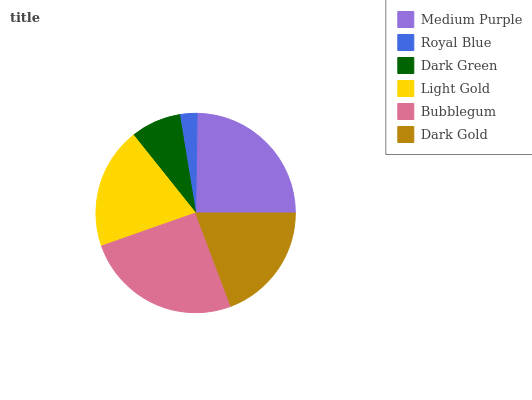Is Royal Blue the minimum?
Answer yes or no. Yes. Is Bubblegum the maximum?
Answer yes or no. Yes. Is Dark Green the minimum?
Answer yes or no. No. Is Dark Green the maximum?
Answer yes or no. No. Is Dark Green greater than Royal Blue?
Answer yes or no. Yes. Is Royal Blue less than Dark Green?
Answer yes or no. Yes. Is Royal Blue greater than Dark Green?
Answer yes or no. No. Is Dark Green less than Royal Blue?
Answer yes or no. No. Is Light Gold the high median?
Answer yes or no. Yes. Is Dark Gold the low median?
Answer yes or no. Yes. Is Medium Purple the high median?
Answer yes or no. No. Is Bubblegum the low median?
Answer yes or no. No. 